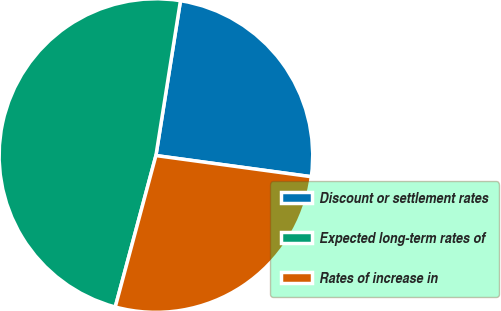<chart> <loc_0><loc_0><loc_500><loc_500><pie_chart><fcel>Discount or settlement rates<fcel>Expected long-term rates of<fcel>Rates of increase in<nl><fcel>24.65%<fcel>48.32%<fcel>27.02%<nl></chart> 